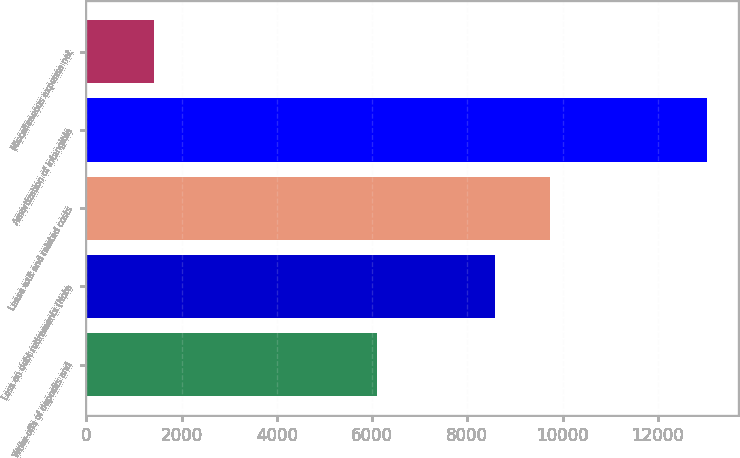Convert chart to OTSL. <chart><loc_0><loc_0><loc_500><loc_500><bar_chart><fcel>Write-offs of deposits and<fcel>Loss on debt retirements (Note<fcel>Lease exit and related costs<fcel>Amortization of intangible<fcel>Miscellaneous expense net<nl><fcel>6099<fcel>8584<fcel>9745.3<fcel>13033<fcel>1420<nl></chart> 